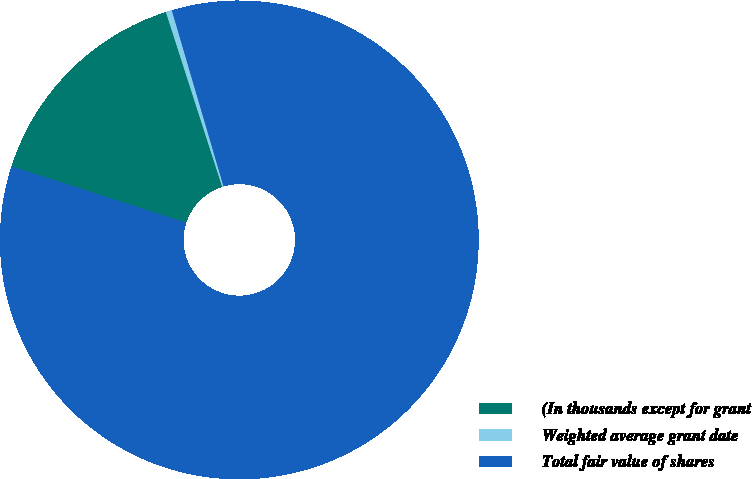Convert chart. <chart><loc_0><loc_0><loc_500><loc_500><pie_chart><fcel>(In thousands except for grant<fcel>Weighted average grant date<fcel>Total fair value of shares<nl><fcel>15.07%<fcel>0.41%<fcel>84.52%<nl></chart> 